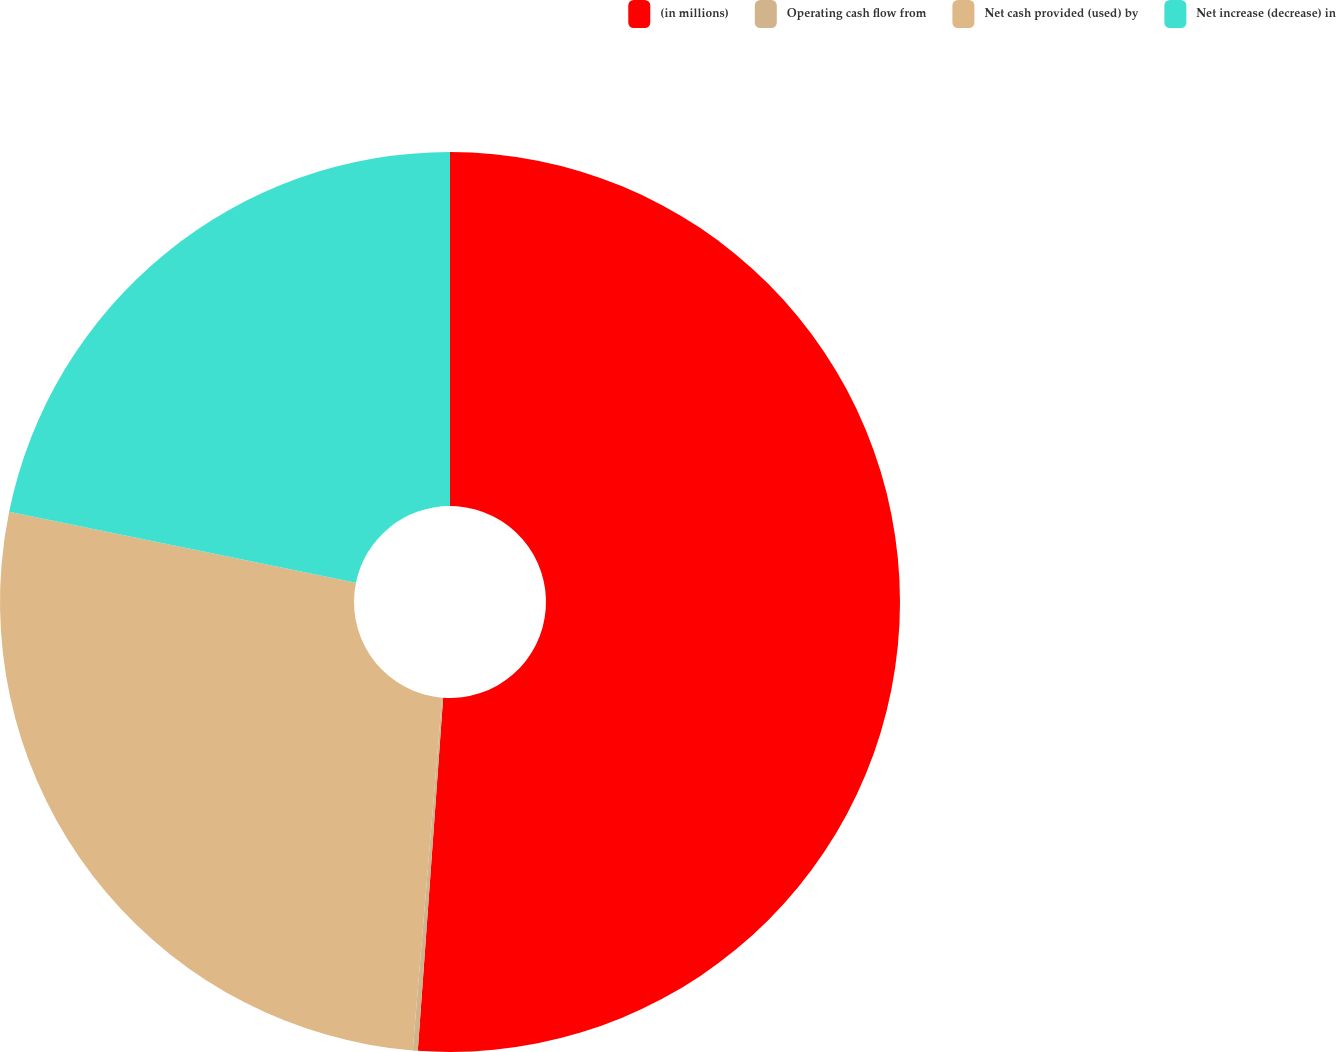<chart> <loc_0><loc_0><loc_500><loc_500><pie_chart><fcel>(in millions)<fcel>Operating cash flow from<fcel>Net cash provided (used) by<fcel>Net increase (decrease) in<nl><fcel>51.14%<fcel>0.18%<fcel>26.89%<fcel>21.79%<nl></chart> 